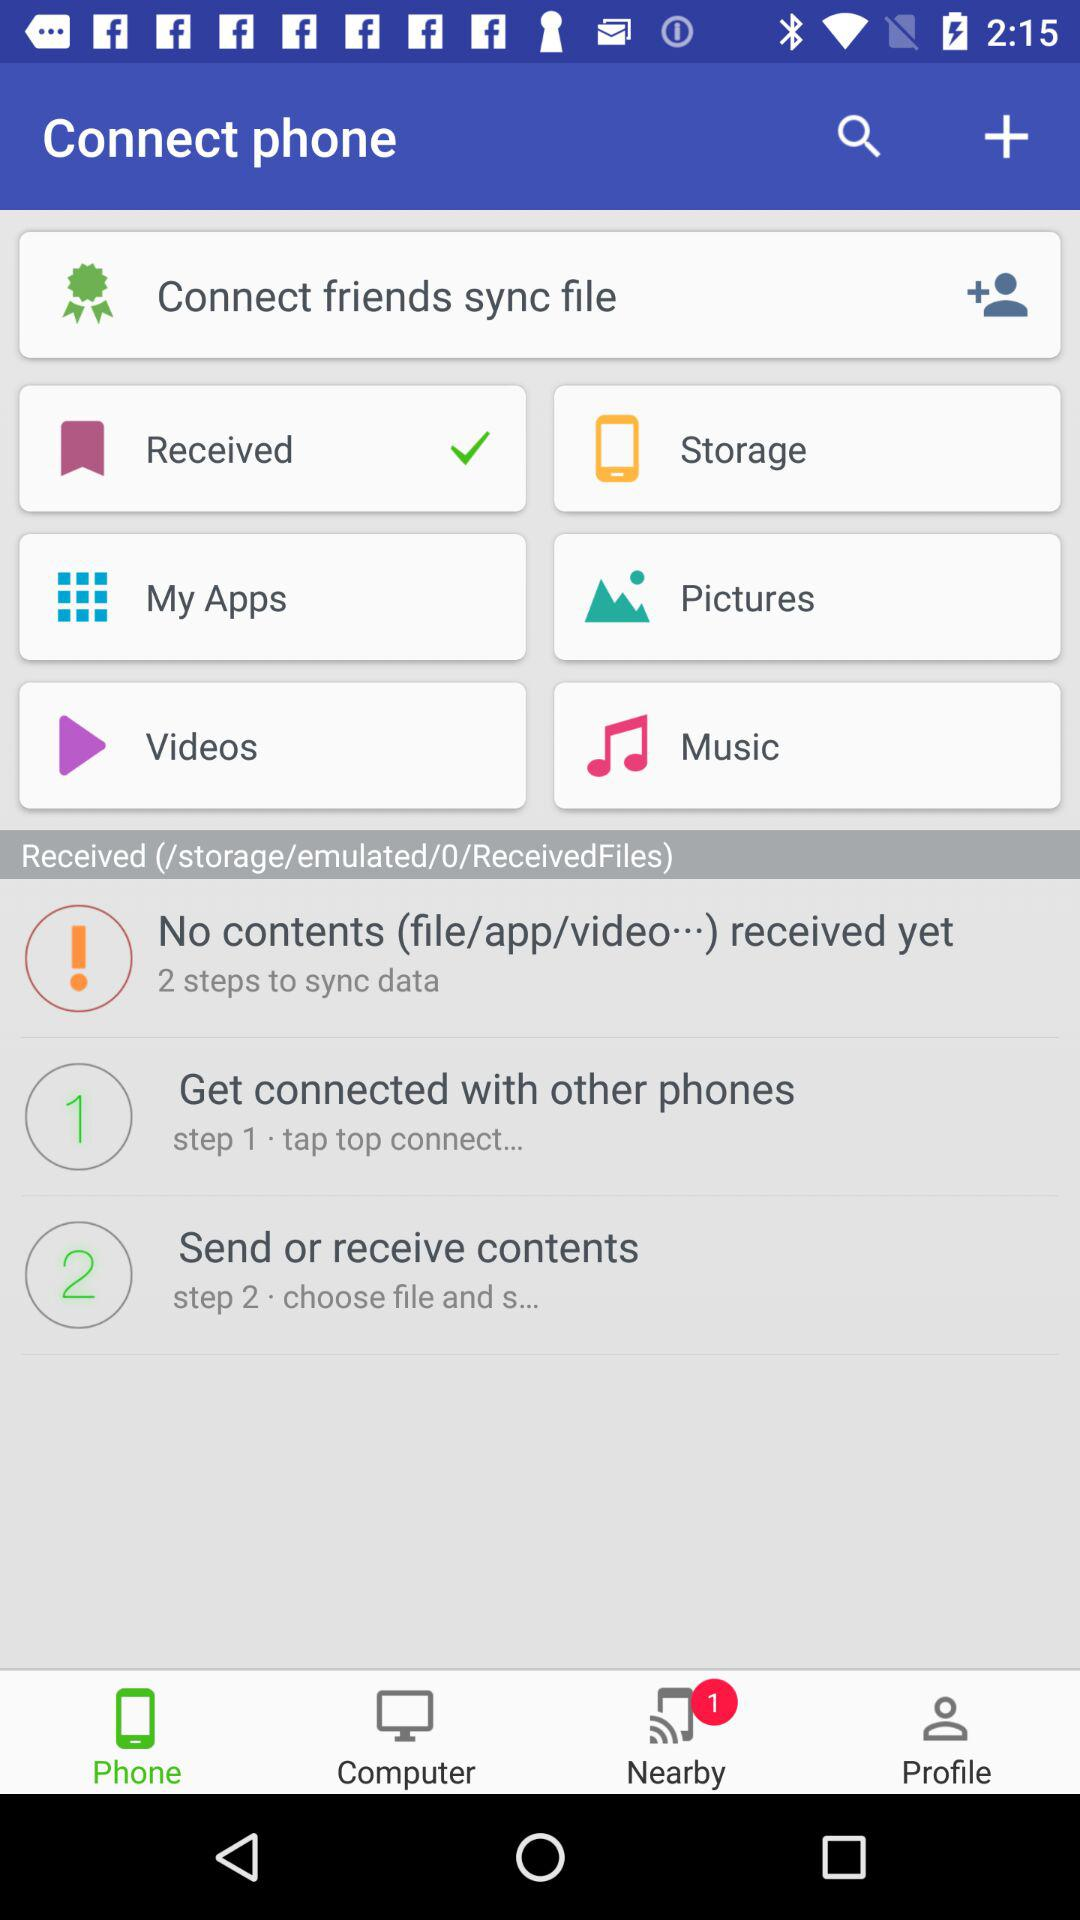What is the number of steps to synchronize data? The number of steps is 2. 